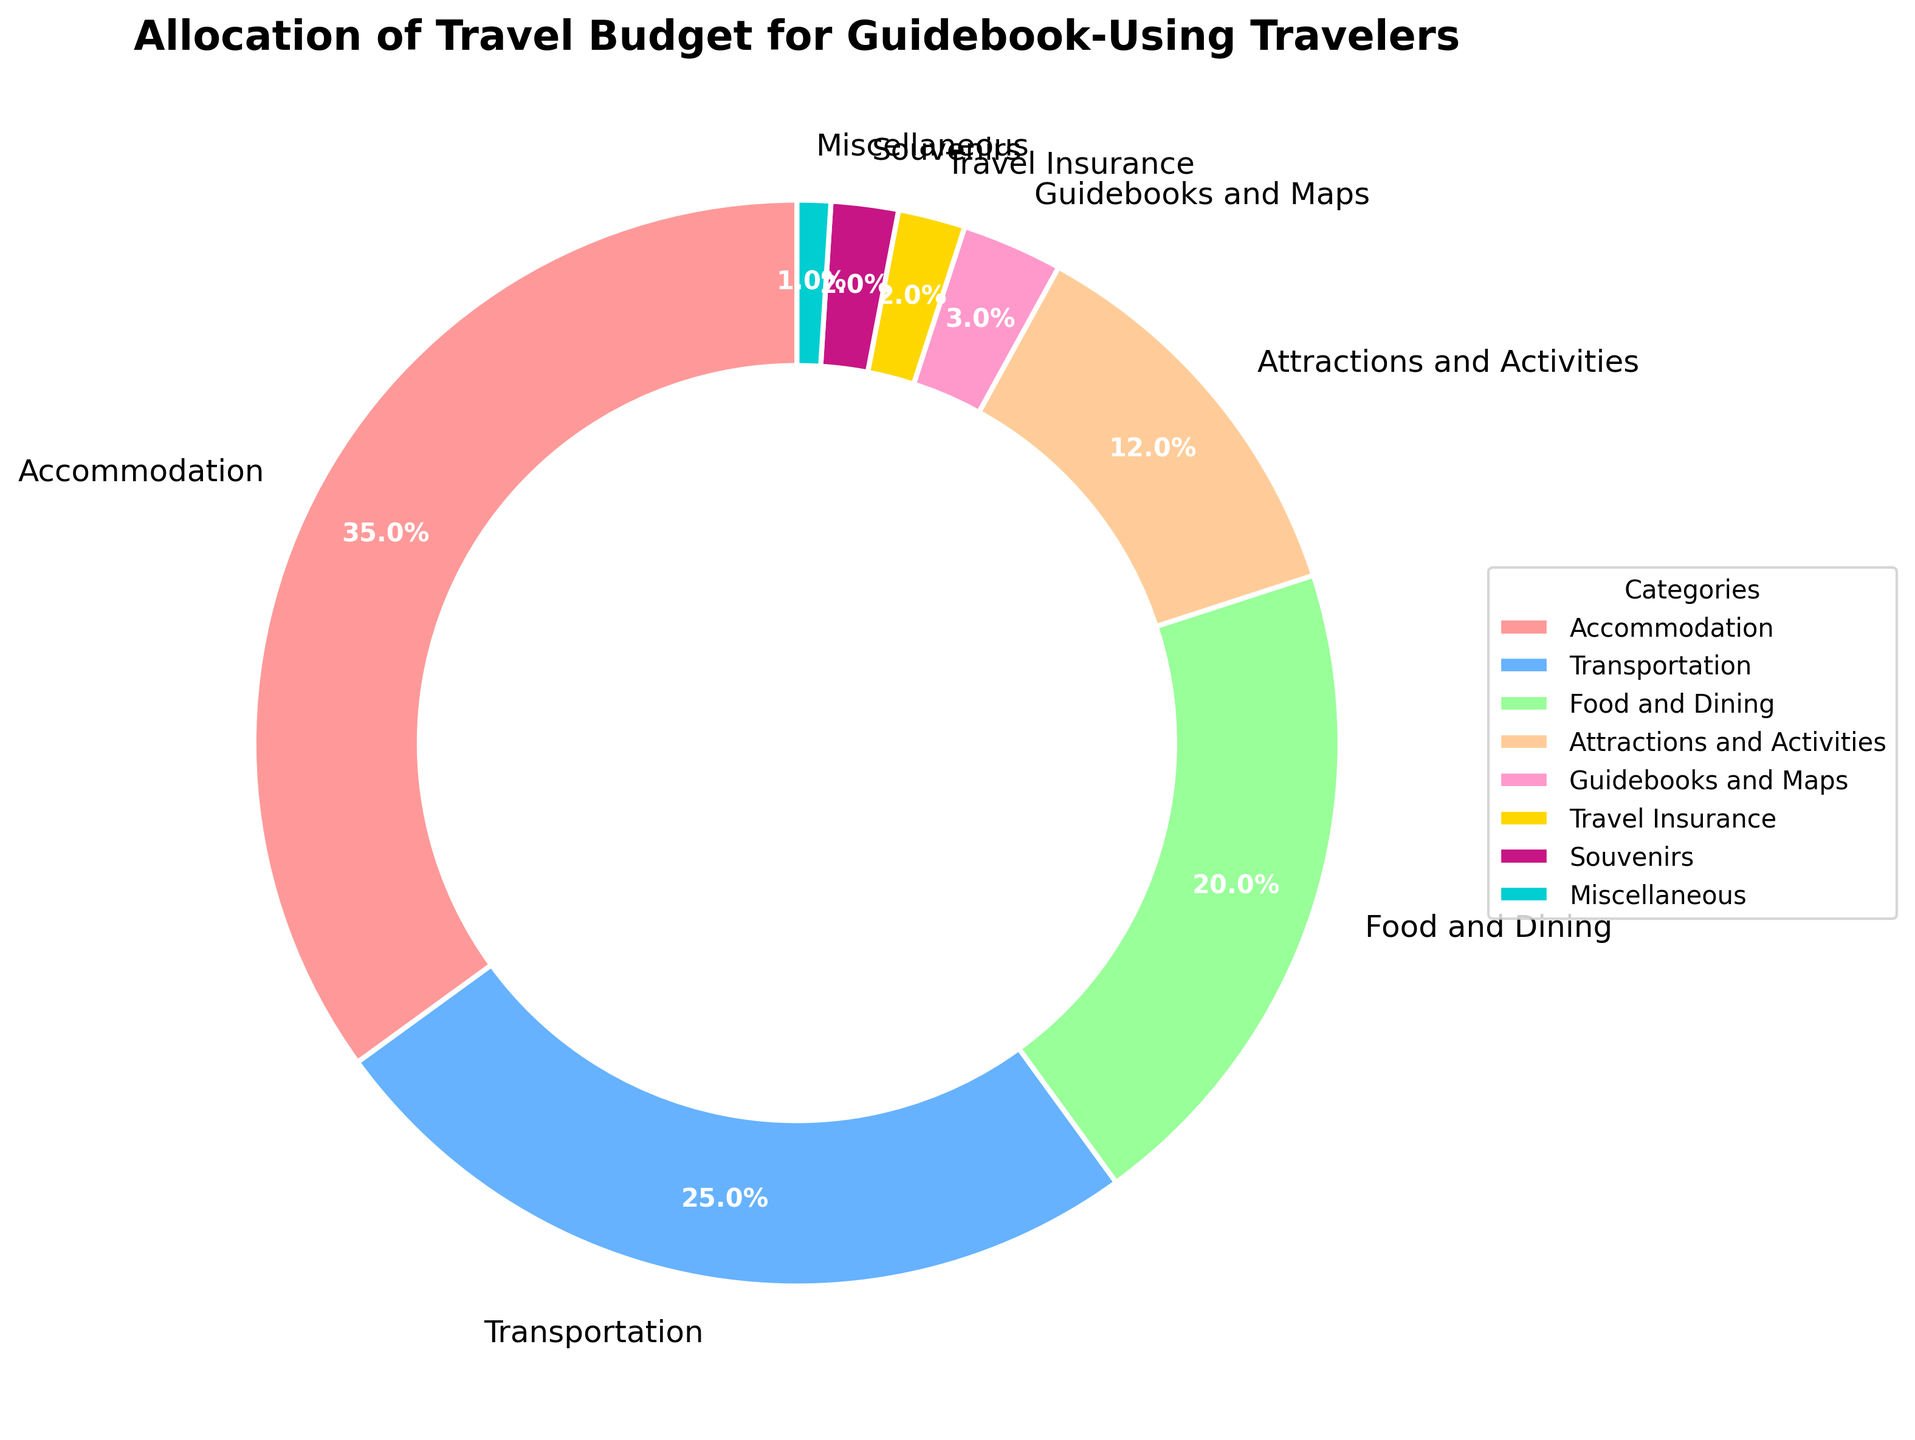What percentage of the budget is allocated to Attractions and Activities and Food and Dining combined? To find the combined percentage, sum the percentages for Attractions and Activities (12%) and Food and Dining (20%): 12 + 20 = 32.
Answer: 32% Which category has a higher allocation: Transportation or Accommodation? By comparing the percentages, Transportation has 25% while Accommodation has 35%. Accommodation has a higher allocation.
Answer: Accommodation What is the difference in budget allocation between Accommodation and Travel Insurance? Subtract the percentage for Travel Insurance (2%) from Accommodation (35%): 35 - 2 = 33.
Answer: 33% Which category receives the smallest budget allocation? The category with the smallest percentage is Miscellaneous, with 1%.
Answer: Miscellaneous How many categories have a budget allocation of 2% or less? The categories with 2% or less allocation are Travel Insurance (2%), Souvenirs (2%), and Miscellaneous (1%). Thus, the count is 3.
Answer: 3 What's the sum of the percentages for categories allocating less than 10% of the budget? The categories with less than 10% allocations are Guidebooks and Maps (3%), Travel Insurance (2%), Souvenirs (2%), and Miscellaneous (1%). Sum: 3 + 2 + 2 + 1 = 8.
Answer: 8% Which slice in the pie chart is colored red? The color red corresponds to the Accommodation category, which has the largest allocation of 35%.
Answer: Accommodation If you had only the Food and Dining budget, how many Guidebooks and Maps categories could you fund with it? The budget for Food and Dining is 20%. The budget for Guidebooks and Maps is 3%. Divide 20 by 3 to find the number of Guidebooks and Maps that could be funded: 20 / 3 ≈ 6.67.
Answer: 6 What is the percentage difference between Transportation and Attractions and Activities? Subtract the percentage for Attractions and Activities (12%) from Transportation (25%): 25 - 12 = 13.
Answer: 13% What two categories together make up nearly half of the total budget? The categories Accommodation (35%) and Transportation (25%) together sum to 60%, which is more than half.
Answer: Accommodation and Transportation 